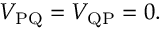<formula> <loc_0><loc_0><loc_500><loc_500>V _ { P Q } = V _ { Q P } = 0 .</formula> 